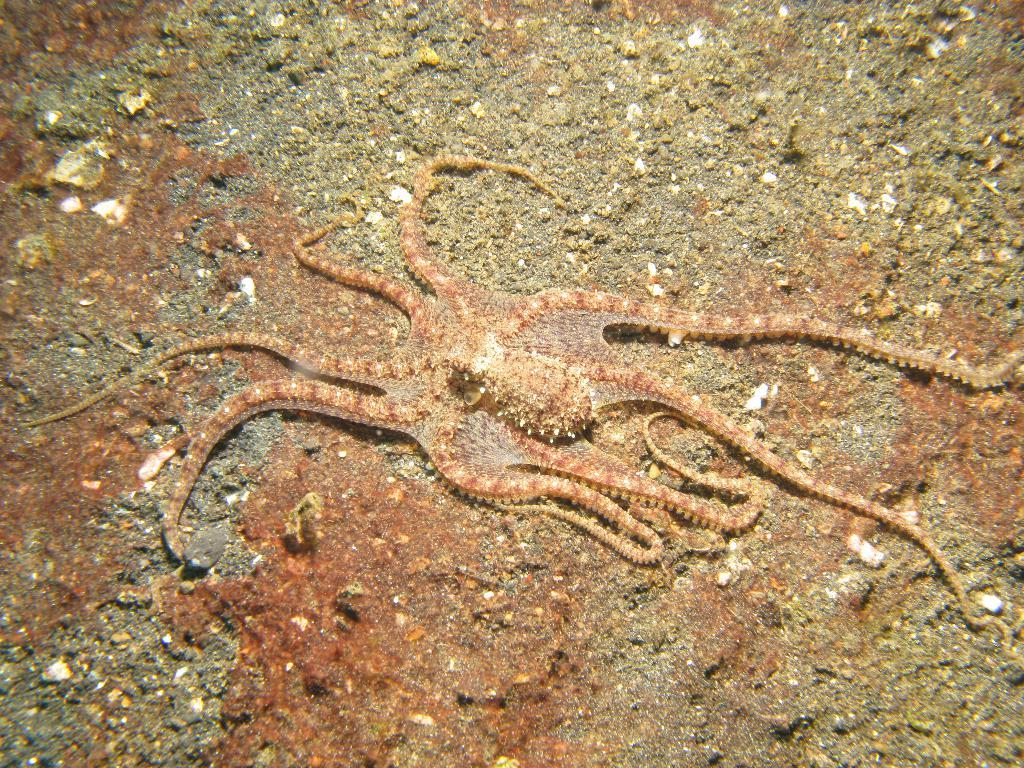What is the main subject of the image? There is an octopus in the image. Where is the octopus located in the image? The octopus is on a path. What type of detail can be seen on the yak in the image? There is no yak present in the image; it features an octopus on a path. Can you point out the location of the map in the image? There is no map present in the image; it only shows an octopus on a path. 